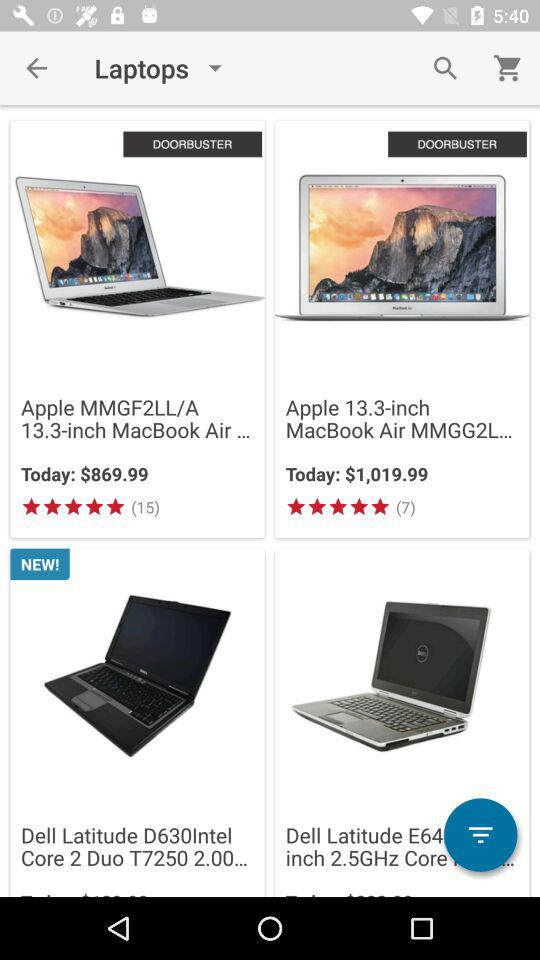What is the price of "Apple 13.3-inch MacBook Air MMGG2L..."? The price of "Apple 13.3-inch MacBook Air MMGG2L..." is $1,019.99. 